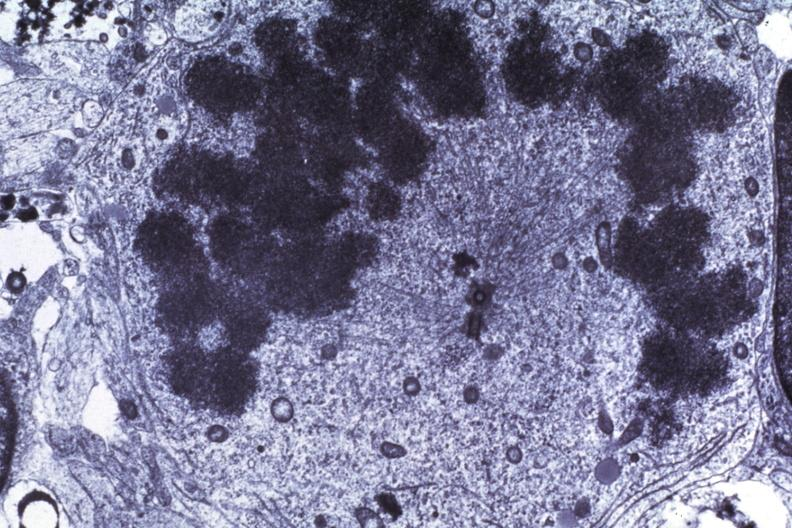what is present?
Answer the question using a single word or phrase. Brain 